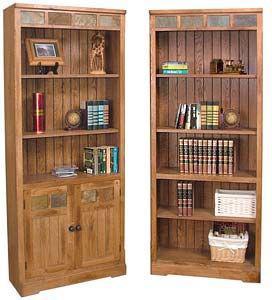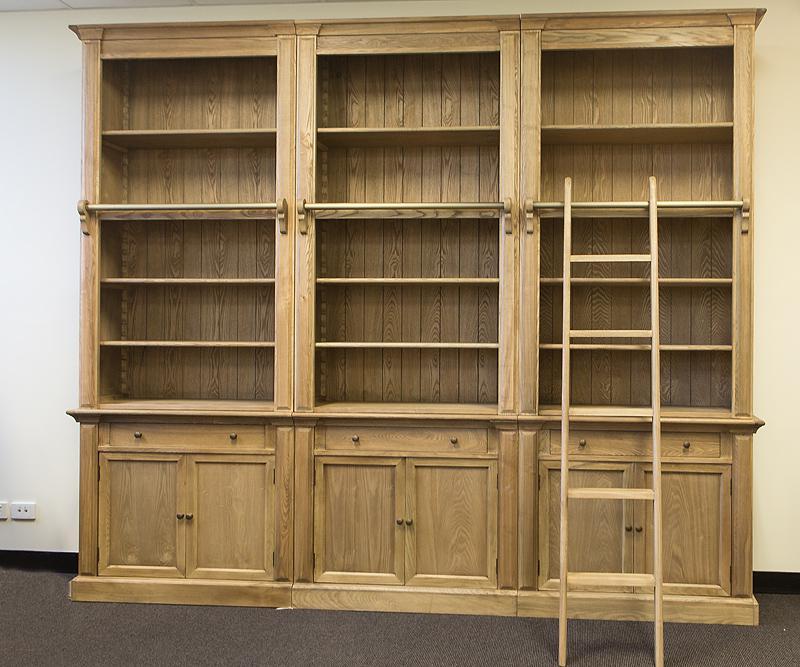The first image is the image on the left, the second image is the image on the right. Evaluate the accuracy of this statement regarding the images: "A bookcase in one image has three side-by-side upper shelf units over six solid doors.". Is it true? Answer yes or no. Yes. The first image is the image on the left, the second image is the image on the right. Assess this claim about the two images: "The shelves have no objects resting on them.". Correct or not? Answer yes or no. No. 